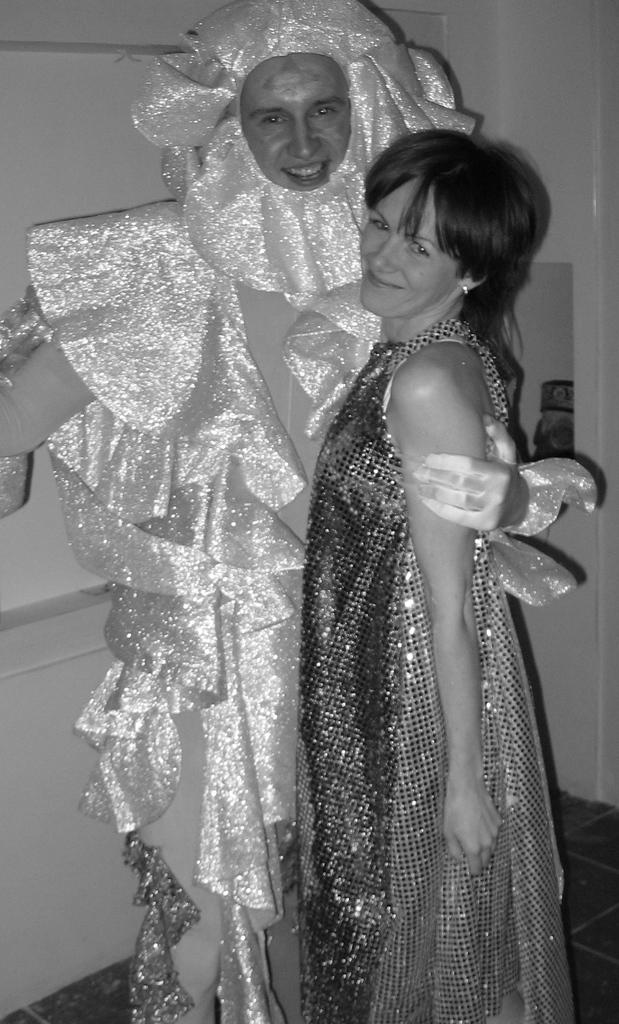What is the color scheme of the image? The image is black and white. How many people are in the image? There is a man and a woman in the image. What are the man and woman wearing? Both the man and woman are wearing costumes. What can be seen in the background of the image? There is a wall visible in the image. What type of expert is providing advice on the wall in the image? There is no expert or advice present in the image; it only features a man and a woman wearing costumes, with a wall visible in the image. 